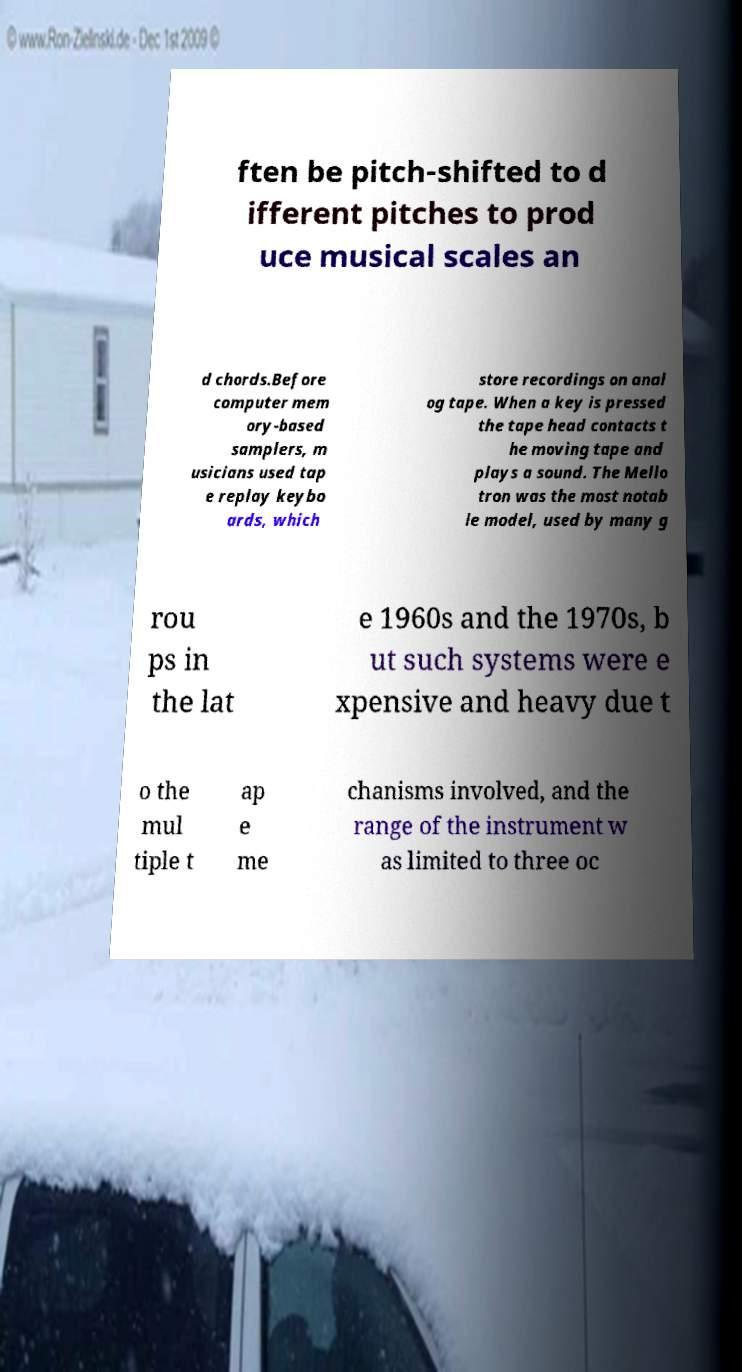I need the written content from this picture converted into text. Can you do that? ften be pitch-shifted to d ifferent pitches to prod uce musical scales an d chords.Before computer mem ory-based samplers, m usicians used tap e replay keybo ards, which store recordings on anal og tape. When a key is pressed the tape head contacts t he moving tape and plays a sound. The Mello tron was the most notab le model, used by many g rou ps in the lat e 1960s and the 1970s, b ut such systems were e xpensive and heavy due t o the mul tiple t ap e me chanisms involved, and the range of the instrument w as limited to three oc 